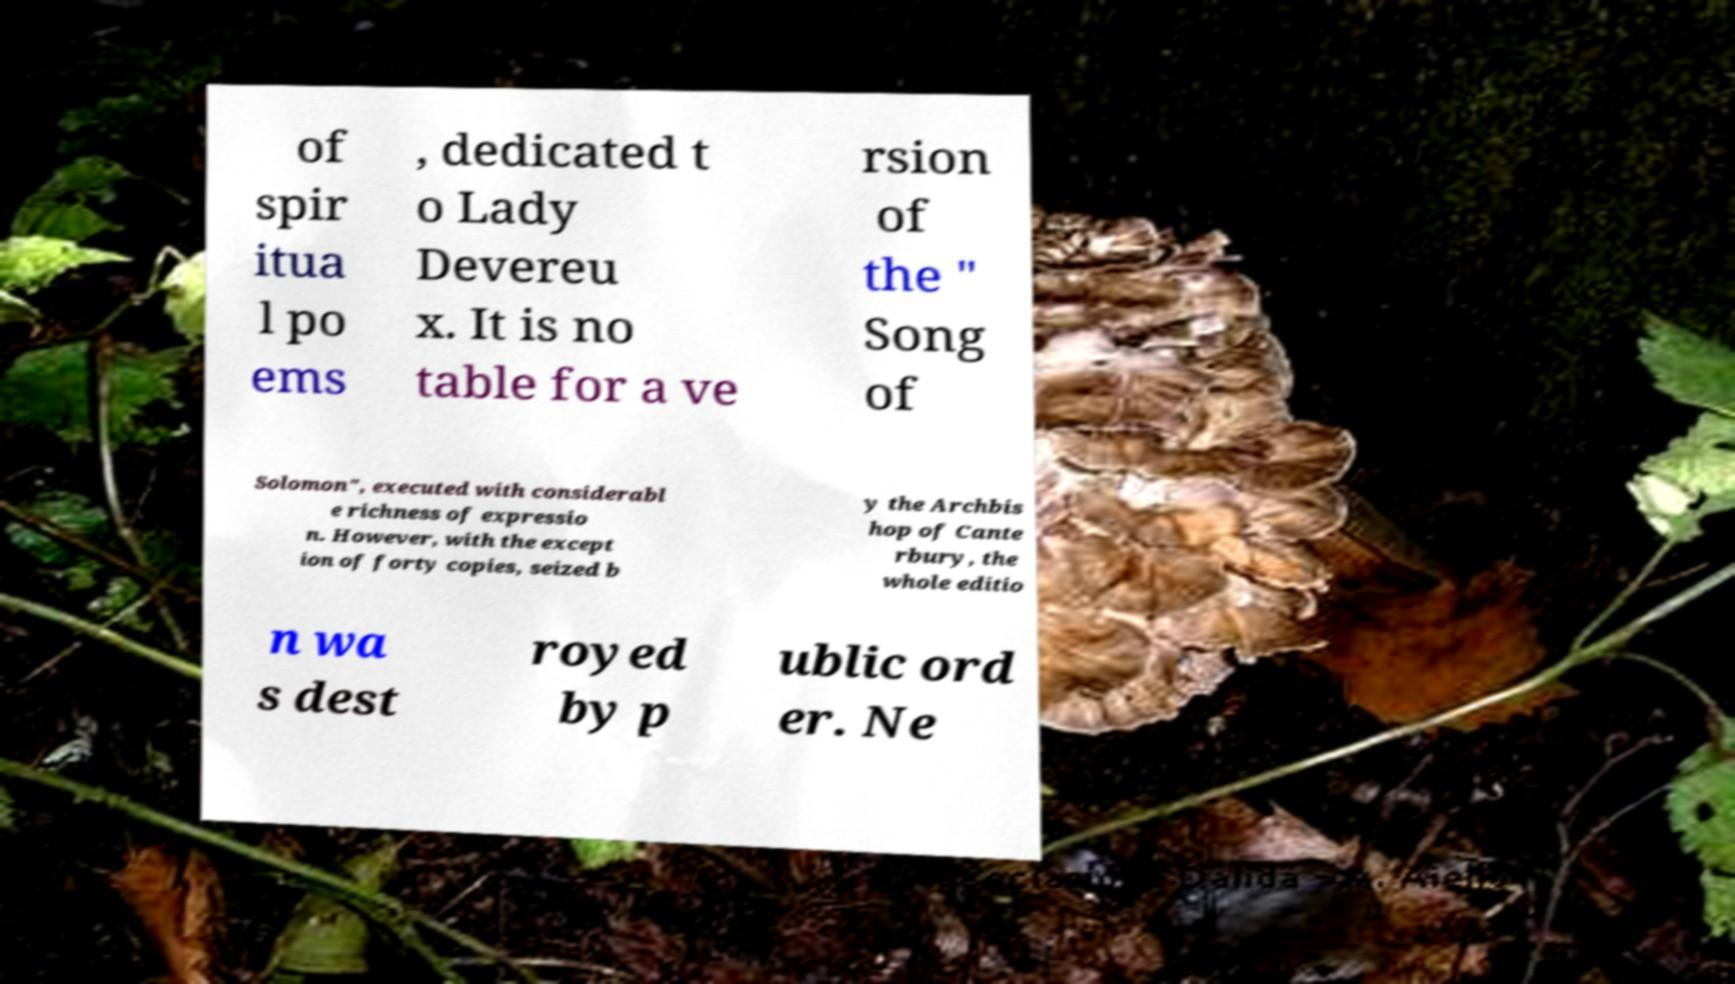Can you read and provide the text displayed in the image?This photo seems to have some interesting text. Can you extract and type it out for me? of spir itua l po ems , dedicated t o Lady Devereu x. It is no table for a ve rsion of the " Song of Solomon", executed with considerabl e richness of expressio n. However, with the except ion of forty copies, seized b y the Archbis hop of Cante rbury, the whole editio n wa s dest royed by p ublic ord er. Ne 